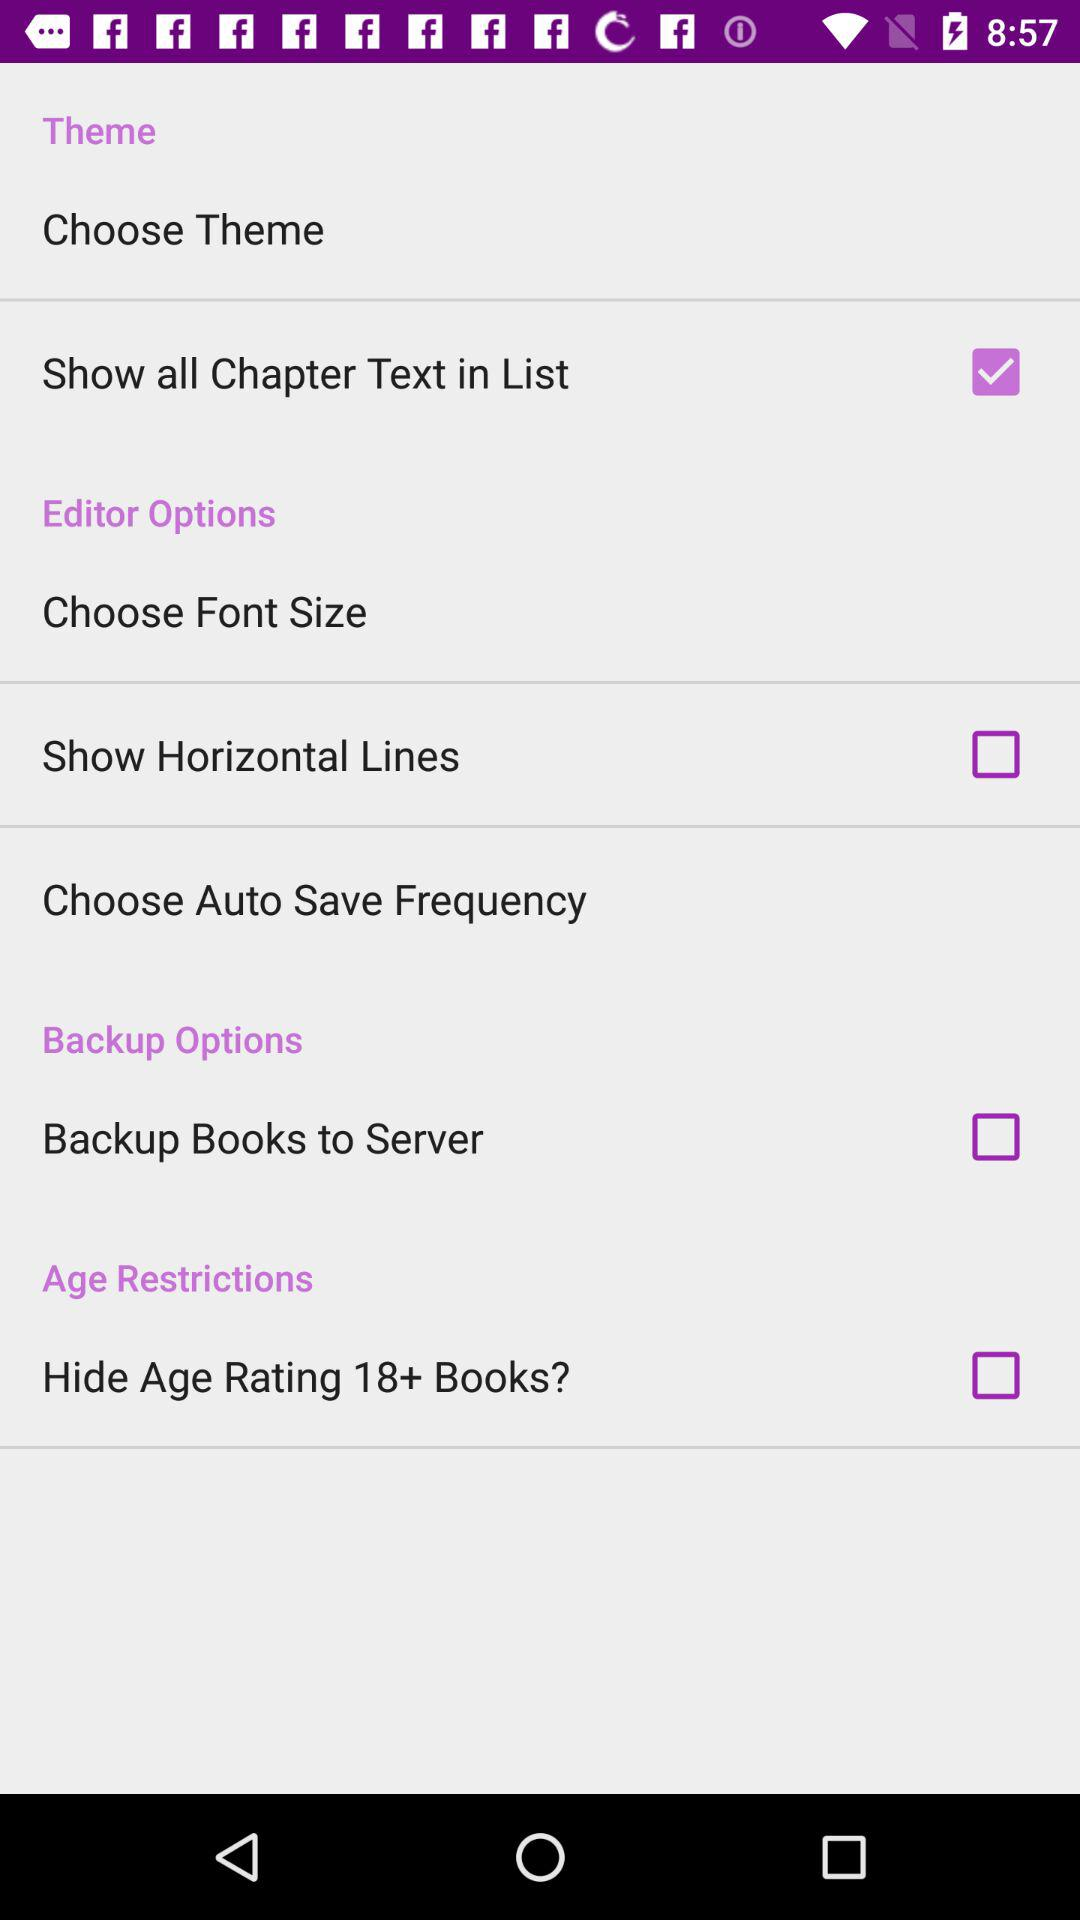How many more items are in the Editor Options section than the Age Restrictions section?
Answer the question using a single word or phrase. 2 